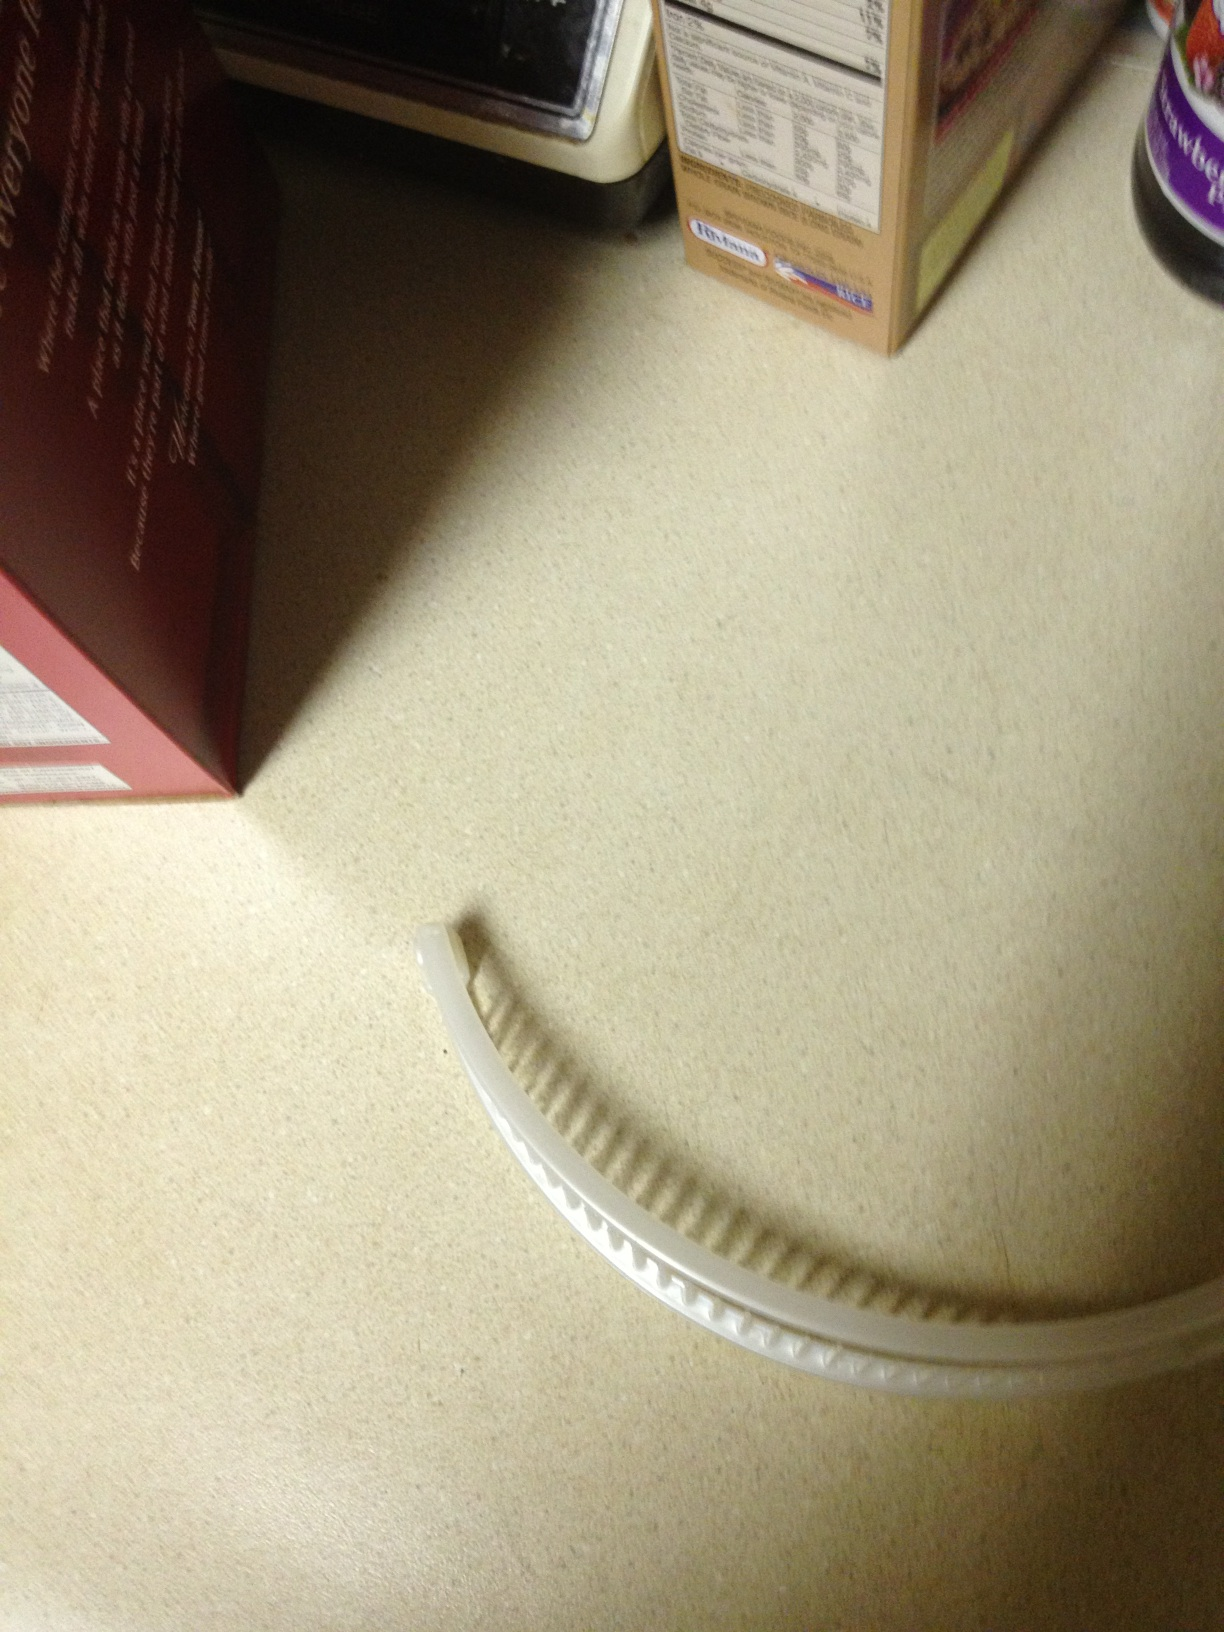Could you suggest occasions where such a banana hair clip could be appropriately worn? This white banana hair clip would be suitable for both casual and semi-formal occasions. Its simplicity and neutral color make it versatile, perfect for a day at the office, a casual lunch, or even for keeping your hair tidy during workouts. 